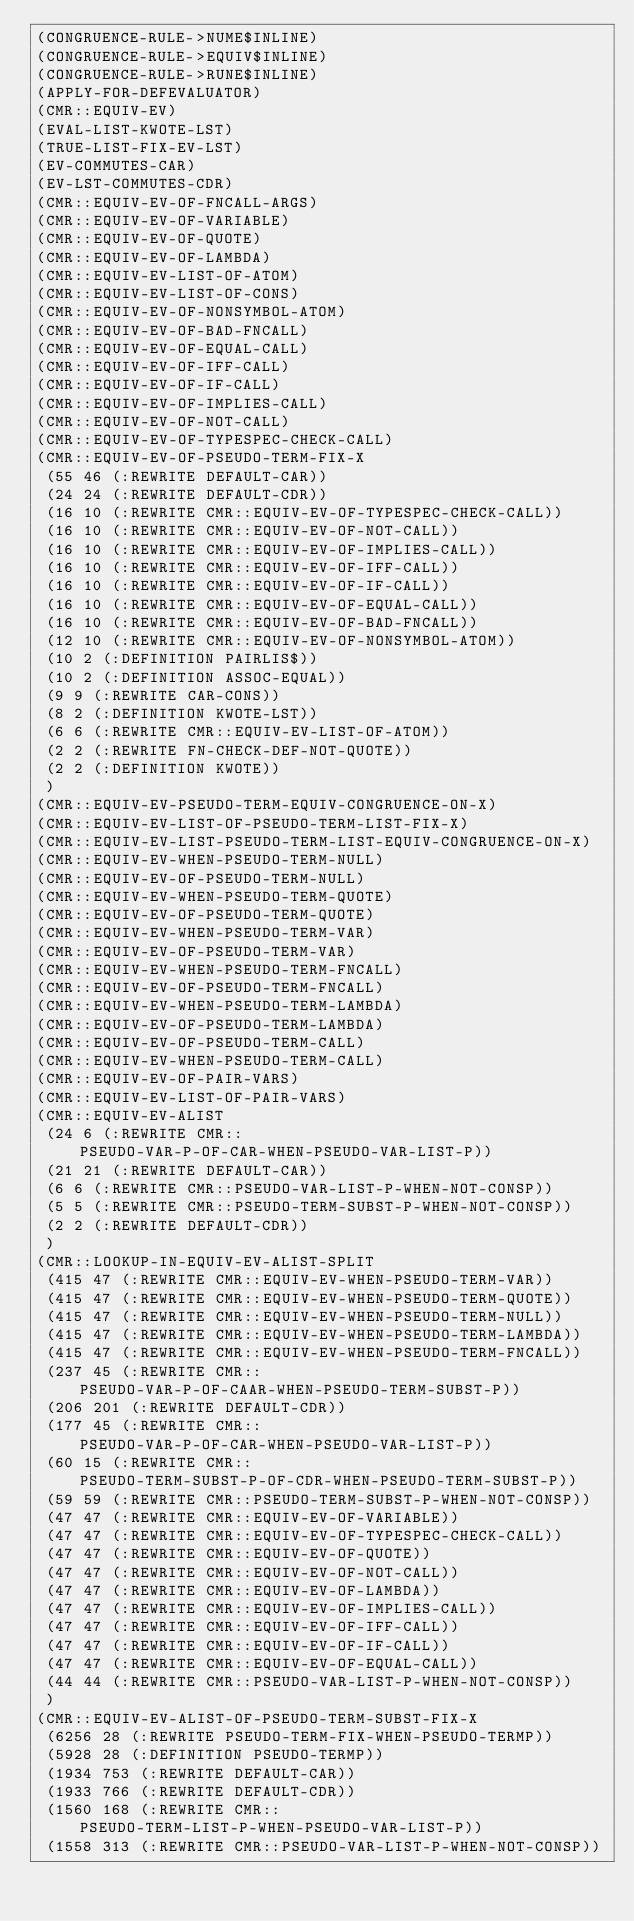<code> <loc_0><loc_0><loc_500><loc_500><_Lisp_>(CONGRUENCE-RULE->NUME$INLINE)
(CONGRUENCE-RULE->EQUIV$INLINE)
(CONGRUENCE-RULE->RUNE$INLINE)
(APPLY-FOR-DEFEVALUATOR)
(CMR::EQUIV-EV)
(EVAL-LIST-KWOTE-LST)
(TRUE-LIST-FIX-EV-LST)
(EV-COMMUTES-CAR)
(EV-LST-COMMUTES-CDR)
(CMR::EQUIV-EV-OF-FNCALL-ARGS)
(CMR::EQUIV-EV-OF-VARIABLE)
(CMR::EQUIV-EV-OF-QUOTE)
(CMR::EQUIV-EV-OF-LAMBDA)
(CMR::EQUIV-EV-LIST-OF-ATOM)
(CMR::EQUIV-EV-LIST-OF-CONS)
(CMR::EQUIV-EV-OF-NONSYMBOL-ATOM)
(CMR::EQUIV-EV-OF-BAD-FNCALL)
(CMR::EQUIV-EV-OF-EQUAL-CALL)
(CMR::EQUIV-EV-OF-IFF-CALL)
(CMR::EQUIV-EV-OF-IF-CALL)
(CMR::EQUIV-EV-OF-IMPLIES-CALL)
(CMR::EQUIV-EV-OF-NOT-CALL)
(CMR::EQUIV-EV-OF-TYPESPEC-CHECK-CALL)
(CMR::EQUIV-EV-OF-PSEUDO-TERM-FIX-X
 (55 46 (:REWRITE DEFAULT-CAR))
 (24 24 (:REWRITE DEFAULT-CDR))
 (16 10 (:REWRITE CMR::EQUIV-EV-OF-TYPESPEC-CHECK-CALL))
 (16 10 (:REWRITE CMR::EQUIV-EV-OF-NOT-CALL))
 (16 10 (:REWRITE CMR::EQUIV-EV-OF-IMPLIES-CALL))
 (16 10 (:REWRITE CMR::EQUIV-EV-OF-IFF-CALL))
 (16 10 (:REWRITE CMR::EQUIV-EV-OF-IF-CALL))
 (16 10 (:REWRITE CMR::EQUIV-EV-OF-EQUAL-CALL))
 (16 10 (:REWRITE CMR::EQUIV-EV-OF-BAD-FNCALL))
 (12 10 (:REWRITE CMR::EQUIV-EV-OF-NONSYMBOL-ATOM))
 (10 2 (:DEFINITION PAIRLIS$))
 (10 2 (:DEFINITION ASSOC-EQUAL))
 (9 9 (:REWRITE CAR-CONS))
 (8 2 (:DEFINITION KWOTE-LST))
 (6 6 (:REWRITE CMR::EQUIV-EV-LIST-OF-ATOM))
 (2 2 (:REWRITE FN-CHECK-DEF-NOT-QUOTE))
 (2 2 (:DEFINITION KWOTE))
 )
(CMR::EQUIV-EV-PSEUDO-TERM-EQUIV-CONGRUENCE-ON-X)
(CMR::EQUIV-EV-LIST-OF-PSEUDO-TERM-LIST-FIX-X)
(CMR::EQUIV-EV-LIST-PSEUDO-TERM-LIST-EQUIV-CONGRUENCE-ON-X)
(CMR::EQUIV-EV-WHEN-PSEUDO-TERM-NULL)
(CMR::EQUIV-EV-OF-PSEUDO-TERM-NULL)
(CMR::EQUIV-EV-WHEN-PSEUDO-TERM-QUOTE)
(CMR::EQUIV-EV-OF-PSEUDO-TERM-QUOTE)
(CMR::EQUIV-EV-WHEN-PSEUDO-TERM-VAR)
(CMR::EQUIV-EV-OF-PSEUDO-TERM-VAR)
(CMR::EQUIV-EV-WHEN-PSEUDO-TERM-FNCALL)
(CMR::EQUIV-EV-OF-PSEUDO-TERM-FNCALL)
(CMR::EQUIV-EV-WHEN-PSEUDO-TERM-LAMBDA)
(CMR::EQUIV-EV-OF-PSEUDO-TERM-LAMBDA)
(CMR::EQUIV-EV-OF-PSEUDO-TERM-CALL)
(CMR::EQUIV-EV-WHEN-PSEUDO-TERM-CALL)
(CMR::EQUIV-EV-OF-PAIR-VARS)
(CMR::EQUIV-EV-LIST-OF-PAIR-VARS)
(CMR::EQUIV-EV-ALIST
 (24 6 (:REWRITE CMR::PSEUDO-VAR-P-OF-CAR-WHEN-PSEUDO-VAR-LIST-P))
 (21 21 (:REWRITE DEFAULT-CAR))
 (6 6 (:REWRITE CMR::PSEUDO-VAR-LIST-P-WHEN-NOT-CONSP))
 (5 5 (:REWRITE CMR::PSEUDO-TERM-SUBST-P-WHEN-NOT-CONSP))
 (2 2 (:REWRITE DEFAULT-CDR))
 )
(CMR::LOOKUP-IN-EQUIV-EV-ALIST-SPLIT
 (415 47 (:REWRITE CMR::EQUIV-EV-WHEN-PSEUDO-TERM-VAR))
 (415 47 (:REWRITE CMR::EQUIV-EV-WHEN-PSEUDO-TERM-QUOTE))
 (415 47 (:REWRITE CMR::EQUIV-EV-WHEN-PSEUDO-TERM-NULL))
 (415 47 (:REWRITE CMR::EQUIV-EV-WHEN-PSEUDO-TERM-LAMBDA))
 (415 47 (:REWRITE CMR::EQUIV-EV-WHEN-PSEUDO-TERM-FNCALL))
 (237 45 (:REWRITE CMR::PSEUDO-VAR-P-OF-CAAR-WHEN-PSEUDO-TERM-SUBST-P))
 (206 201 (:REWRITE DEFAULT-CDR))
 (177 45 (:REWRITE CMR::PSEUDO-VAR-P-OF-CAR-WHEN-PSEUDO-VAR-LIST-P))
 (60 15 (:REWRITE CMR::PSEUDO-TERM-SUBST-P-OF-CDR-WHEN-PSEUDO-TERM-SUBST-P))
 (59 59 (:REWRITE CMR::PSEUDO-TERM-SUBST-P-WHEN-NOT-CONSP))
 (47 47 (:REWRITE CMR::EQUIV-EV-OF-VARIABLE))
 (47 47 (:REWRITE CMR::EQUIV-EV-OF-TYPESPEC-CHECK-CALL))
 (47 47 (:REWRITE CMR::EQUIV-EV-OF-QUOTE))
 (47 47 (:REWRITE CMR::EQUIV-EV-OF-NOT-CALL))
 (47 47 (:REWRITE CMR::EQUIV-EV-OF-LAMBDA))
 (47 47 (:REWRITE CMR::EQUIV-EV-OF-IMPLIES-CALL))
 (47 47 (:REWRITE CMR::EQUIV-EV-OF-IFF-CALL))
 (47 47 (:REWRITE CMR::EQUIV-EV-OF-IF-CALL))
 (47 47 (:REWRITE CMR::EQUIV-EV-OF-EQUAL-CALL))
 (44 44 (:REWRITE CMR::PSEUDO-VAR-LIST-P-WHEN-NOT-CONSP))
 )
(CMR::EQUIV-EV-ALIST-OF-PSEUDO-TERM-SUBST-FIX-X
 (6256 28 (:REWRITE PSEUDO-TERM-FIX-WHEN-PSEUDO-TERMP))
 (5928 28 (:DEFINITION PSEUDO-TERMP))
 (1934 753 (:REWRITE DEFAULT-CAR))
 (1933 766 (:REWRITE DEFAULT-CDR))
 (1560 168 (:REWRITE CMR::PSEUDO-TERM-LIST-P-WHEN-PSEUDO-VAR-LIST-P))
 (1558 313 (:REWRITE CMR::PSEUDO-VAR-LIST-P-WHEN-NOT-CONSP))</code> 